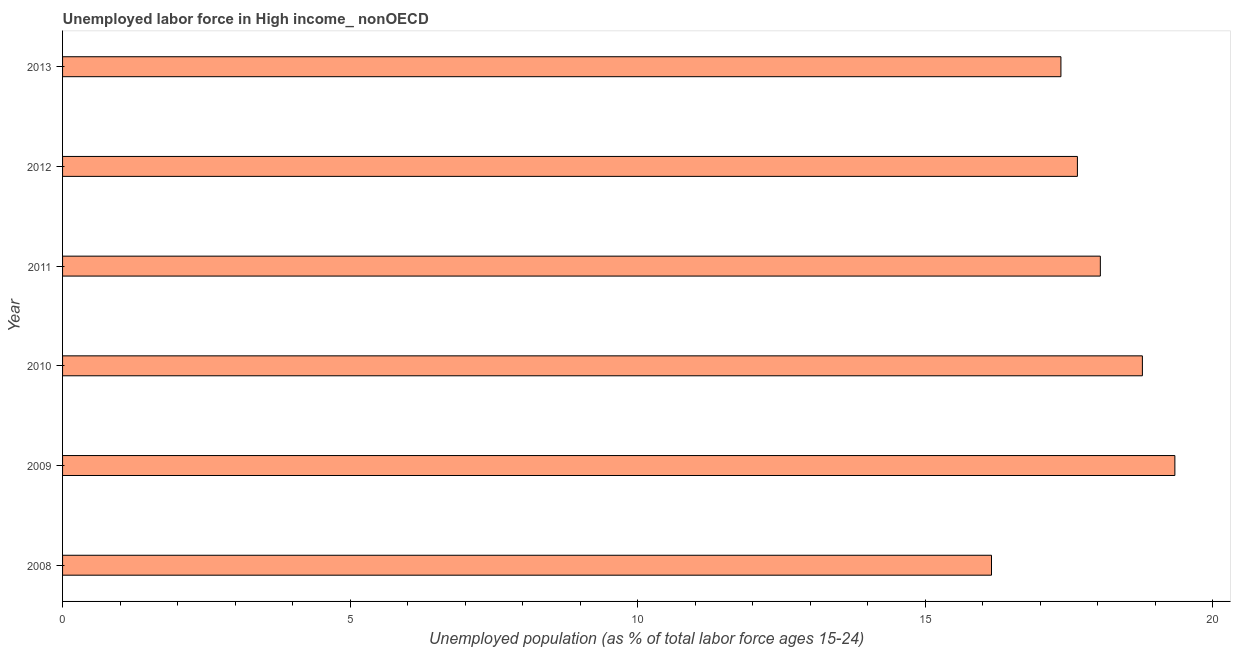Does the graph contain grids?
Ensure brevity in your answer.  No. What is the title of the graph?
Give a very brief answer. Unemployed labor force in High income_ nonOECD. What is the label or title of the X-axis?
Provide a succinct answer. Unemployed population (as % of total labor force ages 15-24). What is the total unemployed youth population in 2013?
Your answer should be compact. 17.36. Across all years, what is the maximum total unemployed youth population?
Offer a terse response. 19.35. Across all years, what is the minimum total unemployed youth population?
Keep it short and to the point. 16.16. In which year was the total unemployed youth population maximum?
Provide a short and direct response. 2009. In which year was the total unemployed youth population minimum?
Your answer should be very brief. 2008. What is the sum of the total unemployed youth population?
Make the answer very short. 107.34. What is the difference between the total unemployed youth population in 2011 and 2013?
Provide a short and direct response. 0.69. What is the average total unemployed youth population per year?
Provide a short and direct response. 17.89. What is the median total unemployed youth population?
Provide a short and direct response. 17.85. What is the ratio of the total unemployed youth population in 2009 to that in 2013?
Keep it short and to the point. 1.11. Is the difference between the total unemployed youth population in 2008 and 2009 greater than the difference between any two years?
Ensure brevity in your answer.  Yes. What is the difference between the highest and the second highest total unemployed youth population?
Your answer should be very brief. 0.56. What is the difference between the highest and the lowest total unemployed youth population?
Offer a very short reply. 3.19. In how many years, is the total unemployed youth population greater than the average total unemployed youth population taken over all years?
Provide a succinct answer. 3. How many bars are there?
Offer a very short reply. 6. Are all the bars in the graph horizontal?
Your response must be concise. Yes. Are the values on the major ticks of X-axis written in scientific E-notation?
Your response must be concise. No. What is the Unemployed population (as % of total labor force ages 15-24) of 2008?
Make the answer very short. 16.16. What is the Unemployed population (as % of total labor force ages 15-24) of 2009?
Keep it short and to the point. 19.35. What is the Unemployed population (as % of total labor force ages 15-24) in 2010?
Make the answer very short. 18.78. What is the Unemployed population (as % of total labor force ages 15-24) in 2011?
Your answer should be compact. 18.05. What is the Unemployed population (as % of total labor force ages 15-24) of 2012?
Your response must be concise. 17.65. What is the Unemployed population (as % of total labor force ages 15-24) in 2013?
Ensure brevity in your answer.  17.36. What is the difference between the Unemployed population (as % of total labor force ages 15-24) in 2008 and 2009?
Provide a succinct answer. -3.19. What is the difference between the Unemployed population (as % of total labor force ages 15-24) in 2008 and 2010?
Give a very brief answer. -2.62. What is the difference between the Unemployed population (as % of total labor force ages 15-24) in 2008 and 2011?
Make the answer very short. -1.89. What is the difference between the Unemployed population (as % of total labor force ages 15-24) in 2008 and 2012?
Give a very brief answer. -1.49. What is the difference between the Unemployed population (as % of total labor force ages 15-24) in 2008 and 2013?
Provide a succinct answer. -1.21. What is the difference between the Unemployed population (as % of total labor force ages 15-24) in 2009 and 2010?
Your response must be concise. 0.57. What is the difference between the Unemployed population (as % of total labor force ages 15-24) in 2009 and 2011?
Offer a terse response. 1.3. What is the difference between the Unemployed population (as % of total labor force ages 15-24) in 2009 and 2012?
Give a very brief answer. 1.7. What is the difference between the Unemployed population (as % of total labor force ages 15-24) in 2009 and 2013?
Give a very brief answer. 1.98. What is the difference between the Unemployed population (as % of total labor force ages 15-24) in 2010 and 2011?
Offer a very short reply. 0.73. What is the difference between the Unemployed population (as % of total labor force ages 15-24) in 2010 and 2012?
Your response must be concise. 1.13. What is the difference between the Unemployed population (as % of total labor force ages 15-24) in 2010 and 2013?
Your answer should be compact. 1.42. What is the difference between the Unemployed population (as % of total labor force ages 15-24) in 2011 and 2012?
Your response must be concise. 0.4. What is the difference between the Unemployed population (as % of total labor force ages 15-24) in 2011 and 2013?
Offer a very short reply. 0.69. What is the difference between the Unemployed population (as % of total labor force ages 15-24) in 2012 and 2013?
Give a very brief answer. 0.29. What is the ratio of the Unemployed population (as % of total labor force ages 15-24) in 2008 to that in 2009?
Make the answer very short. 0.83. What is the ratio of the Unemployed population (as % of total labor force ages 15-24) in 2008 to that in 2010?
Give a very brief answer. 0.86. What is the ratio of the Unemployed population (as % of total labor force ages 15-24) in 2008 to that in 2011?
Ensure brevity in your answer.  0.9. What is the ratio of the Unemployed population (as % of total labor force ages 15-24) in 2008 to that in 2012?
Make the answer very short. 0.92. What is the ratio of the Unemployed population (as % of total labor force ages 15-24) in 2009 to that in 2010?
Offer a terse response. 1.03. What is the ratio of the Unemployed population (as % of total labor force ages 15-24) in 2009 to that in 2011?
Offer a terse response. 1.07. What is the ratio of the Unemployed population (as % of total labor force ages 15-24) in 2009 to that in 2012?
Your answer should be compact. 1.1. What is the ratio of the Unemployed population (as % of total labor force ages 15-24) in 2009 to that in 2013?
Ensure brevity in your answer.  1.11. What is the ratio of the Unemployed population (as % of total labor force ages 15-24) in 2010 to that in 2011?
Provide a short and direct response. 1.04. What is the ratio of the Unemployed population (as % of total labor force ages 15-24) in 2010 to that in 2012?
Provide a short and direct response. 1.06. What is the ratio of the Unemployed population (as % of total labor force ages 15-24) in 2010 to that in 2013?
Offer a terse response. 1.08. What is the ratio of the Unemployed population (as % of total labor force ages 15-24) in 2011 to that in 2012?
Provide a short and direct response. 1.02. What is the ratio of the Unemployed population (as % of total labor force ages 15-24) in 2011 to that in 2013?
Provide a succinct answer. 1.04. 